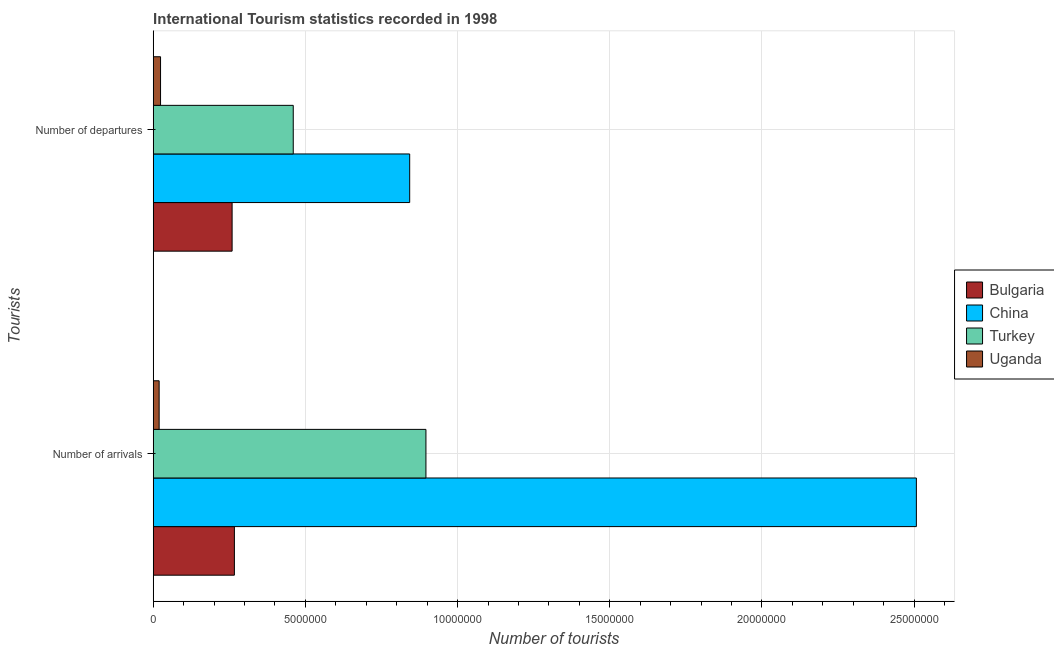How many different coloured bars are there?
Provide a succinct answer. 4. What is the label of the 2nd group of bars from the top?
Provide a succinct answer. Number of arrivals. What is the number of tourist arrivals in Bulgaria?
Your answer should be very brief. 2.67e+06. Across all countries, what is the maximum number of tourist arrivals?
Your answer should be very brief. 2.51e+07. Across all countries, what is the minimum number of tourist arrivals?
Offer a terse response. 1.95e+05. In which country was the number of tourist arrivals maximum?
Offer a terse response. China. In which country was the number of tourist arrivals minimum?
Make the answer very short. Uganda. What is the total number of tourist arrivals in the graph?
Your response must be concise. 3.69e+07. What is the difference between the number of tourist departures in Turkey and that in China?
Keep it short and to the point. -3.82e+06. What is the difference between the number of tourist departures in Uganda and the number of tourist arrivals in China?
Offer a very short reply. -2.48e+07. What is the average number of tourist arrivals per country?
Your response must be concise. 9.22e+06. What is the difference between the number of tourist arrivals and number of tourist departures in Bulgaria?
Keep it short and to the point. 7.50e+04. What is the ratio of the number of tourist arrivals in Bulgaria to that in China?
Offer a terse response. 0.11. In how many countries, is the number of tourist arrivals greater than the average number of tourist arrivals taken over all countries?
Your response must be concise. 1. What does the 1st bar from the top in Number of arrivals represents?
Offer a terse response. Uganda. What does the 4th bar from the bottom in Number of arrivals represents?
Provide a short and direct response. Uganda. How many countries are there in the graph?
Offer a terse response. 4. Are the values on the major ticks of X-axis written in scientific E-notation?
Offer a terse response. No. Does the graph contain any zero values?
Ensure brevity in your answer.  No. Where does the legend appear in the graph?
Offer a terse response. Center right. How many legend labels are there?
Give a very brief answer. 4. What is the title of the graph?
Ensure brevity in your answer.  International Tourism statistics recorded in 1998. What is the label or title of the X-axis?
Your response must be concise. Number of tourists. What is the label or title of the Y-axis?
Provide a short and direct response. Tourists. What is the Number of tourists in Bulgaria in Number of arrivals?
Keep it short and to the point. 2.67e+06. What is the Number of tourists in China in Number of arrivals?
Your response must be concise. 2.51e+07. What is the Number of tourists in Turkey in Number of arrivals?
Provide a short and direct response. 8.96e+06. What is the Number of tourists of Uganda in Number of arrivals?
Offer a very short reply. 1.95e+05. What is the Number of tourists in Bulgaria in Number of departures?
Ensure brevity in your answer.  2.59e+06. What is the Number of tourists in China in Number of departures?
Provide a short and direct response. 8.43e+06. What is the Number of tourists in Turkey in Number of departures?
Your answer should be compact. 4.60e+06. What is the Number of tourists of Uganda in Number of departures?
Offer a terse response. 2.41e+05. Across all Tourists, what is the maximum Number of tourists of Bulgaria?
Give a very brief answer. 2.67e+06. Across all Tourists, what is the maximum Number of tourists of China?
Offer a terse response. 2.51e+07. Across all Tourists, what is the maximum Number of tourists of Turkey?
Provide a short and direct response. 8.96e+06. Across all Tourists, what is the maximum Number of tourists of Uganda?
Your answer should be compact. 2.41e+05. Across all Tourists, what is the minimum Number of tourists of Bulgaria?
Ensure brevity in your answer.  2.59e+06. Across all Tourists, what is the minimum Number of tourists of China?
Your answer should be very brief. 8.43e+06. Across all Tourists, what is the minimum Number of tourists of Turkey?
Your answer should be compact. 4.60e+06. Across all Tourists, what is the minimum Number of tourists of Uganda?
Your answer should be compact. 1.95e+05. What is the total Number of tourists in Bulgaria in the graph?
Keep it short and to the point. 5.26e+06. What is the total Number of tourists of China in the graph?
Give a very brief answer. 3.35e+07. What is the total Number of tourists of Turkey in the graph?
Offer a very short reply. 1.36e+07. What is the total Number of tourists in Uganda in the graph?
Your answer should be compact. 4.36e+05. What is the difference between the Number of tourists of Bulgaria in Number of arrivals and that in Number of departures?
Your answer should be compact. 7.50e+04. What is the difference between the Number of tourists in China in Number of arrivals and that in Number of departures?
Offer a terse response. 1.66e+07. What is the difference between the Number of tourists of Turkey in Number of arrivals and that in Number of departures?
Offer a very short reply. 4.36e+06. What is the difference between the Number of tourists in Uganda in Number of arrivals and that in Number of departures?
Your answer should be very brief. -4.60e+04. What is the difference between the Number of tourists in Bulgaria in Number of arrivals and the Number of tourists in China in Number of departures?
Your answer should be compact. -5.76e+06. What is the difference between the Number of tourists of Bulgaria in Number of arrivals and the Number of tourists of Turkey in Number of departures?
Offer a terse response. -1.93e+06. What is the difference between the Number of tourists of Bulgaria in Number of arrivals and the Number of tourists of Uganda in Number of departures?
Provide a short and direct response. 2.43e+06. What is the difference between the Number of tourists of China in Number of arrivals and the Number of tourists of Turkey in Number of departures?
Give a very brief answer. 2.05e+07. What is the difference between the Number of tourists in China in Number of arrivals and the Number of tourists in Uganda in Number of departures?
Make the answer very short. 2.48e+07. What is the difference between the Number of tourists in Turkey in Number of arrivals and the Number of tourists in Uganda in Number of departures?
Your answer should be compact. 8.72e+06. What is the average Number of tourists in Bulgaria per Tourists?
Give a very brief answer. 2.63e+06. What is the average Number of tourists of China per Tourists?
Your answer should be very brief. 1.67e+07. What is the average Number of tourists of Turkey per Tourists?
Offer a terse response. 6.78e+06. What is the average Number of tourists of Uganda per Tourists?
Give a very brief answer. 2.18e+05. What is the difference between the Number of tourists in Bulgaria and Number of tourists in China in Number of arrivals?
Your answer should be compact. -2.24e+07. What is the difference between the Number of tourists of Bulgaria and Number of tourists of Turkey in Number of arrivals?
Make the answer very short. -6.29e+06. What is the difference between the Number of tourists of Bulgaria and Number of tourists of Uganda in Number of arrivals?
Ensure brevity in your answer.  2.47e+06. What is the difference between the Number of tourists in China and Number of tourists in Turkey in Number of arrivals?
Offer a very short reply. 1.61e+07. What is the difference between the Number of tourists of China and Number of tourists of Uganda in Number of arrivals?
Your response must be concise. 2.49e+07. What is the difference between the Number of tourists in Turkey and Number of tourists in Uganda in Number of arrivals?
Your response must be concise. 8.76e+06. What is the difference between the Number of tourists in Bulgaria and Number of tourists in China in Number of departures?
Your response must be concise. -5.83e+06. What is the difference between the Number of tourists in Bulgaria and Number of tourists in Turkey in Number of departures?
Your response must be concise. -2.01e+06. What is the difference between the Number of tourists in Bulgaria and Number of tourists in Uganda in Number of departures?
Offer a very short reply. 2.35e+06. What is the difference between the Number of tourists of China and Number of tourists of Turkey in Number of departures?
Keep it short and to the point. 3.82e+06. What is the difference between the Number of tourists of China and Number of tourists of Uganda in Number of departures?
Give a very brief answer. 8.18e+06. What is the difference between the Number of tourists of Turkey and Number of tourists of Uganda in Number of departures?
Your answer should be compact. 4.36e+06. What is the ratio of the Number of tourists of Bulgaria in Number of arrivals to that in Number of departures?
Keep it short and to the point. 1.03. What is the ratio of the Number of tourists of China in Number of arrivals to that in Number of departures?
Offer a very short reply. 2.98. What is the ratio of the Number of tourists of Turkey in Number of arrivals to that in Number of departures?
Your answer should be compact. 1.95. What is the ratio of the Number of tourists of Uganda in Number of arrivals to that in Number of departures?
Provide a succinct answer. 0.81. What is the difference between the highest and the second highest Number of tourists in Bulgaria?
Keep it short and to the point. 7.50e+04. What is the difference between the highest and the second highest Number of tourists of China?
Ensure brevity in your answer.  1.66e+07. What is the difference between the highest and the second highest Number of tourists of Turkey?
Your answer should be compact. 4.36e+06. What is the difference between the highest and the second highest Number of tourists in Uganda?
Your response must be concise. 4.60e+04. What is the difference between the highest and the lowest Number of tourists of Bulgaria?
Ensure brevity in your answer.  7.50e+04. What is the difference between the highest and the lowest Number of tourists of China?
Your answer should be very brief. 1.66e+07. What is the difference between the highest and the lowest Number of tourists of Turkey?
Your answer should be compact. 4.36e+06. What is the difference between the highest and the lowest Number of tourists in Uganda?
Your response must be concise. 4.60e+04. 